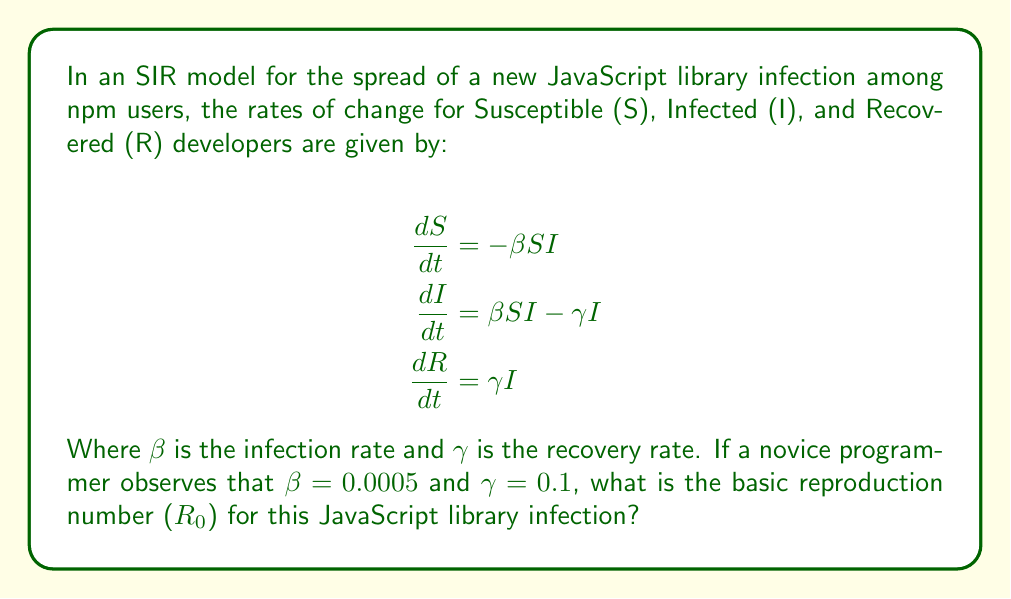Give your solution to this math problem. To solve this problem, we need to understand the concept of the basic reproduction number ($R_0$) in the context of an SIR model. The basic reproduction number is a key parameter in epidemiology that represents the average number of secondary infections caused by one infected individual in a completely susceptible population.

For an SIR model, the basic reproduction number is given by the formula:

$$R_0 = \frac{\beta}{\gamma}$$

Where:
- $\beta$ is the infection rate
- $\gamma$ is the recovery rate

In this case, we are given:
- $\beta = 0.0005$
- $\gamma = 0.1$

To calculate $R_0$, we simply divide $\beta$ by $\gamma$:

$$R_0 = \frac{0.0005}{0.1} = 0.005$$

This value of $R_0$ is less than 1, which indicates that the JavaScript library infection is not likely to spread widely among npm users. In epidemiological terms, this suggests that each infected developer is expected to infect less than one new developer before recovering, on average.

For a novice programmer learning about npm, this result implies that the new JavaScript library is not likely to become very popular or widely adopted in the npm ecosystem, based on the current infection and recovery rates.
Answer: $R_0 = 0.005$ 